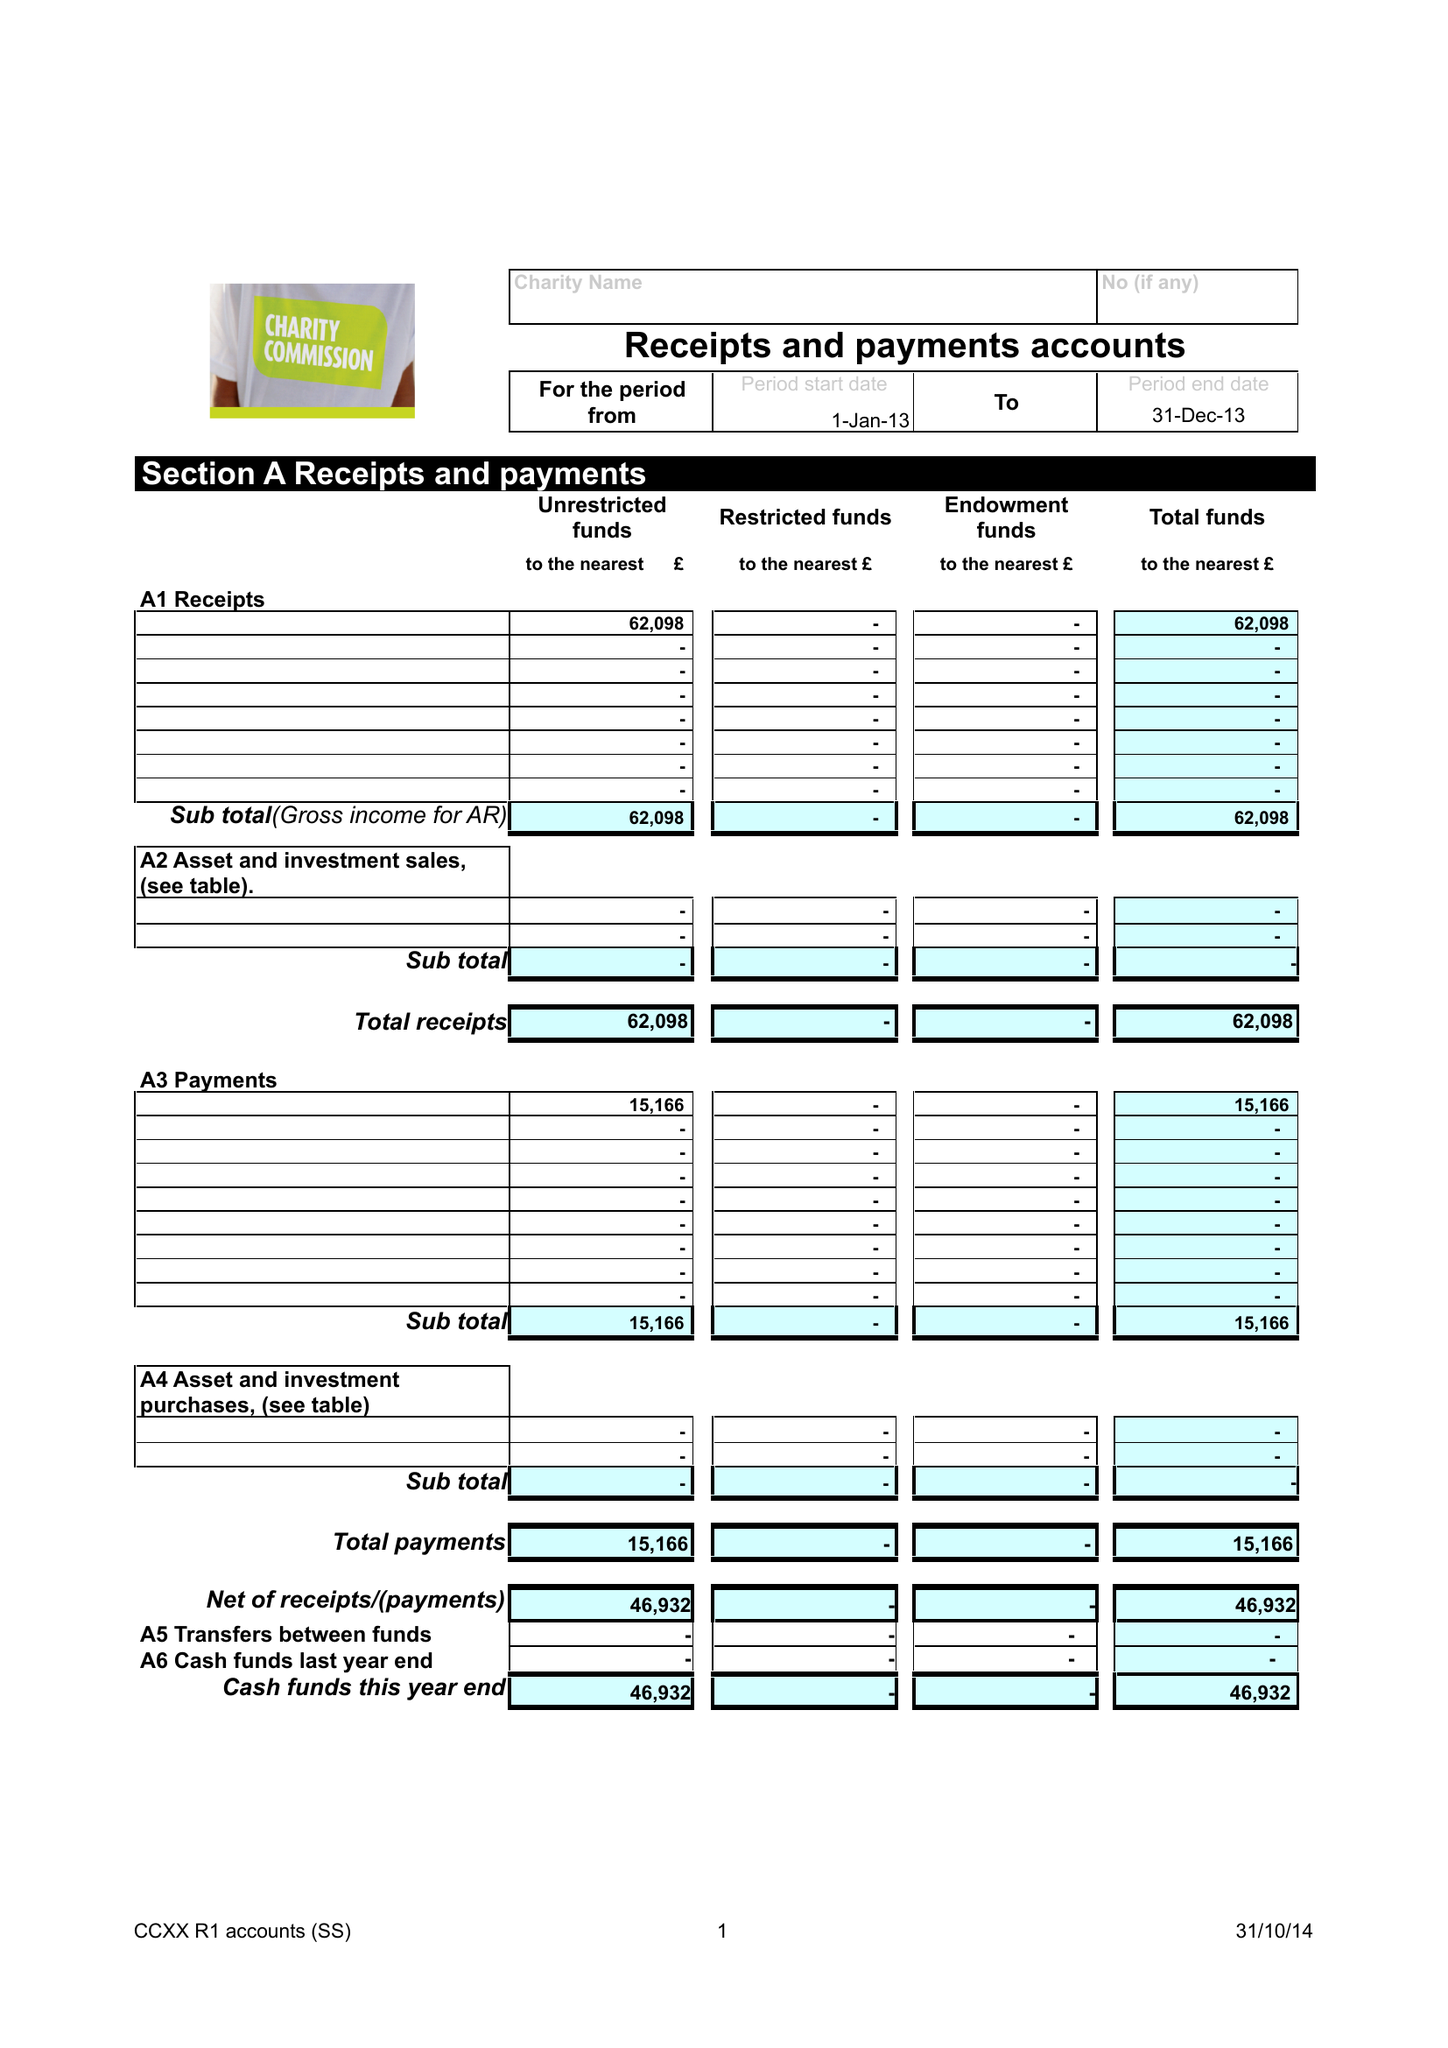What is the value for the address__street_line?
Answer the question using a single word or phrase. None 